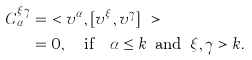Convert formula to latex. <formula><loc_0><loc_0><loc_500><loc_500>C _ { \alpha } ^ { \xi \gamma } & = \ < v ^ { \alpha } , [ v ^ { \xi } , v ^ { \gamma } ] \ > \\ & = 0 , \quad \text {if} \quad \alpha \leq k \, \text { and } \, \xi , \gamma > k .</formula> 